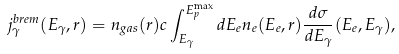<formula> <loc_0><loc_0><loc_500><loc_500>j _ { \gamma } ^ { b r e m } ( E _ { \gamma } , r ) = n _ { g a s } ( r ) c \int _ { E _ { \gamma } } ^ { E _ { p } ^ { \max } } d E _ { e } n _ { e } ( E _ { e } , r ) \frac { d \sigma } { d E _ { \gamma } } ( E _ { e } , E _ { \gamma } ) ,</formula> 